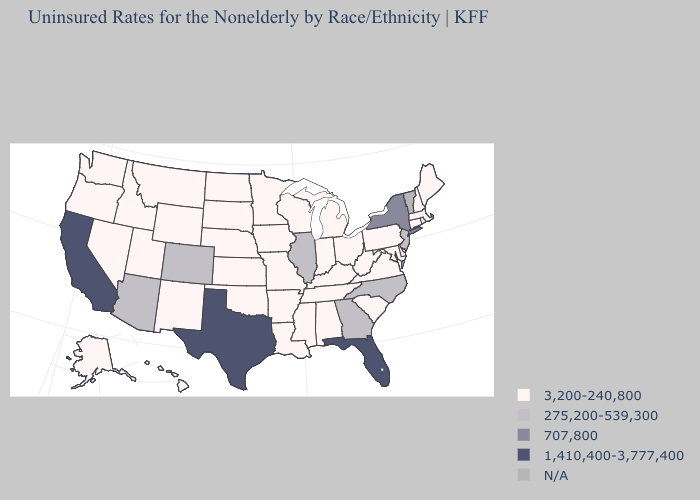Among the states that border Indiana , which have the highest value?
Be succinct. Illinois. Name the states that have a value in the range 275,200-539,300?
Short answer required. Arizona, Colorado, Georgia, Illinois, New Jersey, North Carolina. What is the lowest value in states that border Oregon?
Short answer required. 3,200-240,800. What is the highest value in states that border Maryland?
Keep it brief. 3,200-240,800. What is the lowest value in the MidWest?
Write a very short answer. 3,200-240,800. How many symbols are there in the legend?
Quick response, please. 5. What is the lowest value in states that border Iowa?
Keep it brief. 3,200-240,800. What is the highest value in the MidWest ?
Be succinct. 275,200-539,300. What is the highest value in the USA?
Write a very short answer. 1,410,400-3,777,400. What is the value of Maryland?
Quick response, please. 3,200-240,800. Does the first symbol in the legend represent the smallest category?
Write a very short answer. Yes. Among the states that border Kentucky , which have the lowest value?
Answer briefly. Indiana, Missouri, Ohio, Tennessee, Virginia, West Virginia. Is the legend a continuous bar?
Concise answer only. No. 